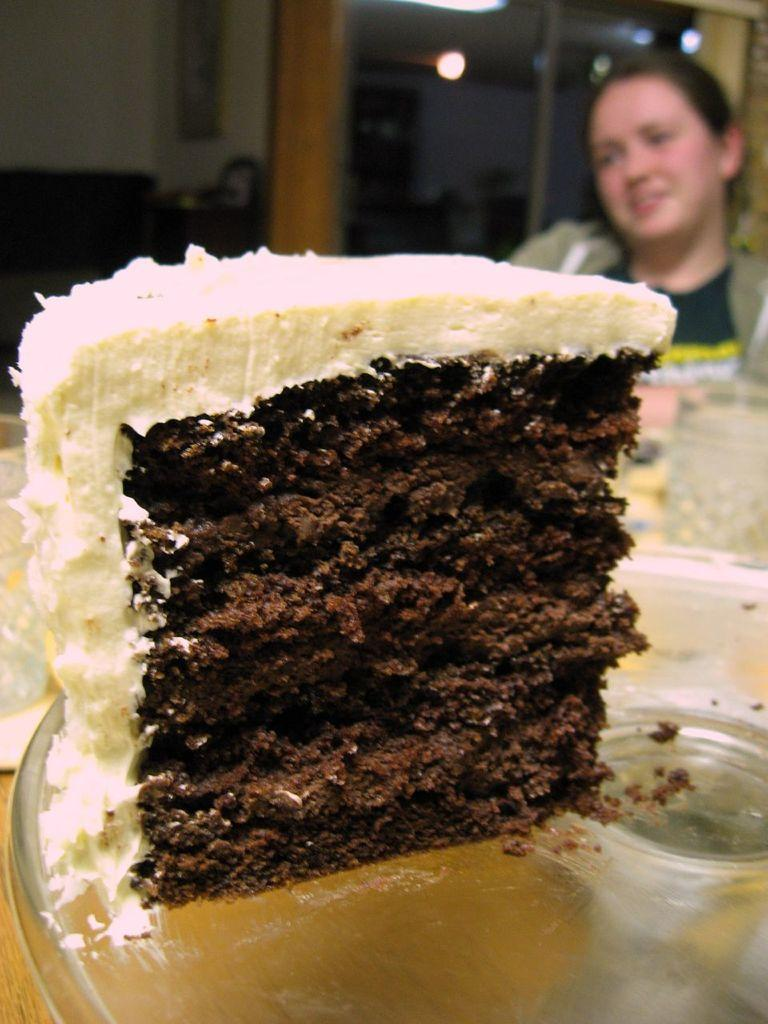What type of dessert is on the plate in the image? There is a piece of cake with cream on a plate in the image. Can you describe the person in the image? There is a person sitting in the image. What can be said about the background of the image? The background of the image is blurry. What type of cannon is being used by the person in the image? There is no cannon present in the image. What kind of apparel is the person wearing in the image? The provided facts do not mention the person's apparel, so we cannot answer this question definitively. Can you tell me how many pencils are visible in the image? There are no pencils visible in the image. 